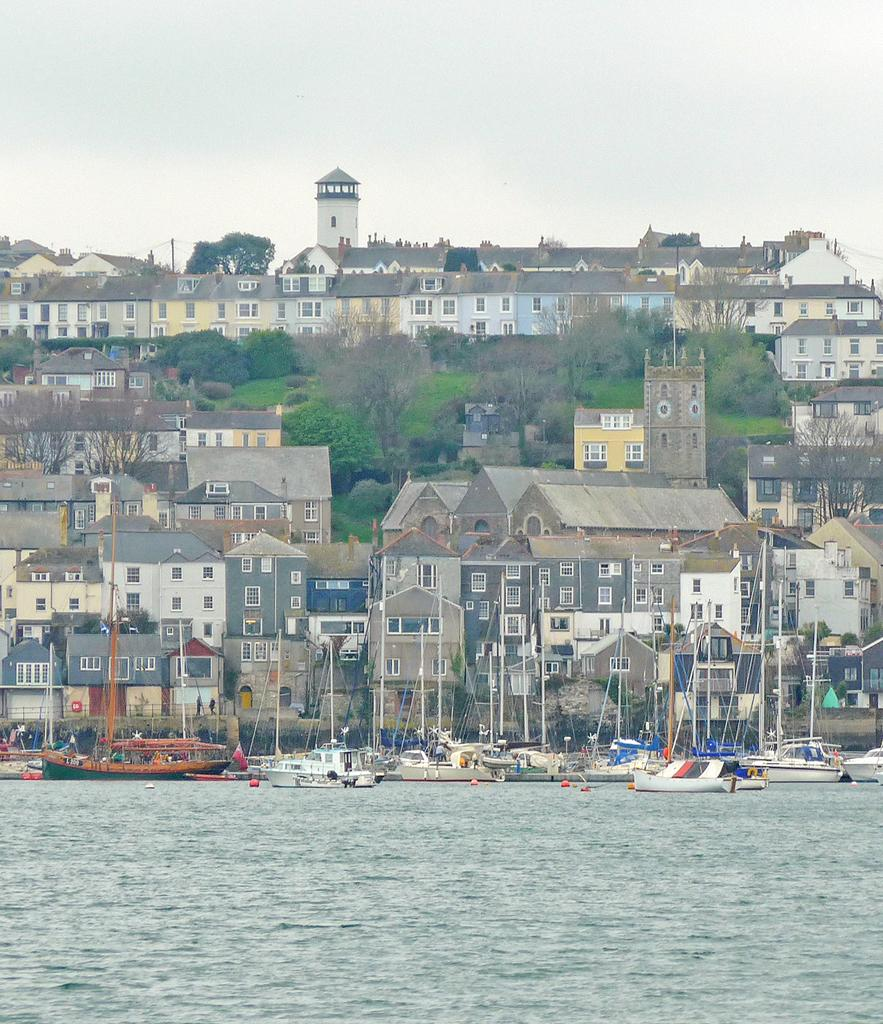What is in the water in the image? There are boats in the water in the image. What can be seen in the background of the image? There are buildings and trees with green color in the background. What is the color of the sky in the image? The sky is white in color. Where is the library located in the image? There is no library present in the image. What type of thrill can be experienced while looking at the image? The image does not depict any thrilling activities or experiences. 